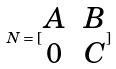Convert formula to latex. <formula><loc_0><loc_0><loc_500><loc_500>N = [ \begin{matrix} A & B \\ 0 & C \end{matrix} ]</formula> 